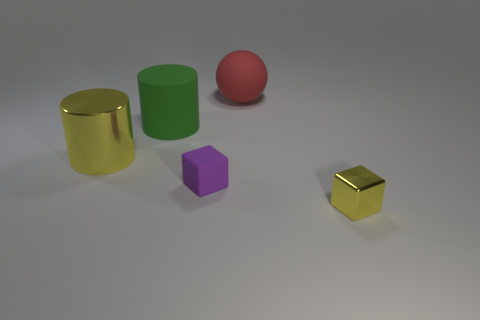Do the purple rubber object and the yellow thing that is left of the big matte sphere have the same shape?
Give a very brief answer. No. What number of other metal cubes have the same size as the purple block?
Give a very brief answer. 1. There is a yellow object that is the same shape as the tiny purple rubber object; what is its material?
Your response must be concise. Metal. There is a metal block right of the rubber cylinder; does it have the same color as the shiny object behind the tiny metallic block?
Give a very brief answer. Yes. What is the shape of the yellow thing on the left side of the tiny metallic cube?
Provide a succinct answer. Cylinder. What color is the metal cube?
Offer a terse response. Yellow. The red object that is made of the same material as the purple thing is what shape?
Your response must be concise. Sphere. Is the size of the yellow shiny object to the right of the sphere the same as the small purple matte thing?
Your answer should be compact. Yes. What number of things are either objects to the right of the purple block or objects that are behind the tiny yellow cube?
Provide a short and direct response. 5. Does the small cube that is right of the sphere have the same color as the large metal cylinder?
Provide a succinct answer. Yes. 